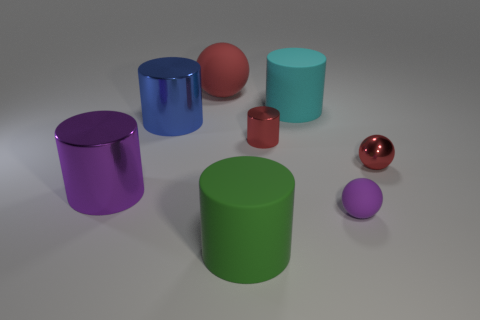Subtract all brown balls. Subtract all purple blocks. How many balls are left? 3 Add 2 gray objects. How many objects exist? 10 Subtract all spheres. How many objects are left? 5 Add 7 red cylinders. How many red cylinders are left? 8 Add 5 tiny red spheres. How many tiny red spheres exist? 6 Subtract 0 cyan spheres. How many objects are left? 8 Subtract all small red rubber spheres. Subtract all red rubber things. How many objects are left? 7 